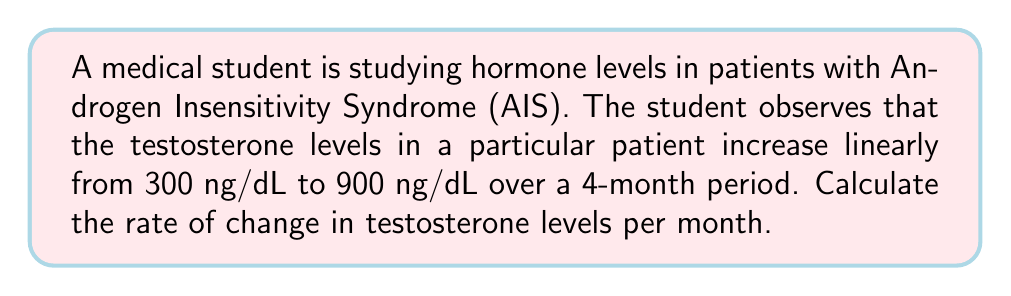Help me with this question. To solve this problem, we need to use the concept of rate of change, which is essentially the slope of the linear function representing the hormone levels over time.

The rate of change formula is:

$$ \text{Rate of change} = \frac{\text{Change in y}}{\text{Change in x}} = \frac{\Delta y}{\Delta x} $$

Where:
- $\Delta y$ is the change in hormone levels (testosterone in this case)
- $\Delta x$ is the change in time

Given:
- Initial testosterone level: 300 ng/dL
- Final testosterone level: 900 ng/dL
- Time period: 4 months

Let's calculate:

1) Change in testosterone levels (Δy):
   $\Delta y = 900 \text{ ng/dL} - 300 \text{ ng/dL} = 600 \text{ ng/dL}$

2) Change in time (Δx):
   $\Delta x = 4 \text{ months}$

3) Apply the rate of change formula:

   $$ \text{Rate of change} = \frac{\Delta y}{\Delta x} = \frac{600 \text{ ng/dL}}{4 \text{ months}} = 150 \text{ ng/dL per month} $$

Therefore, the rate of change in testosterone levels is 150 ng/dL per month.
Answer: $150 \text{ ng/dL per month}$ 